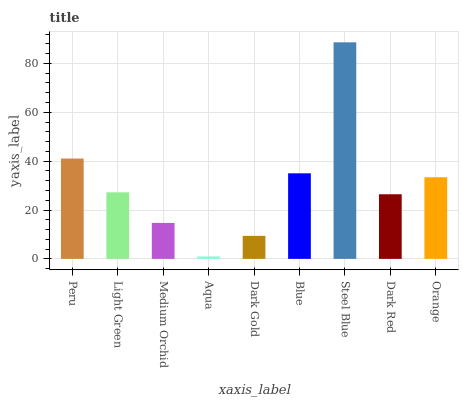Is Light Green the minimum?
Answer yes or no. No. Is Light Green the maximum?
Answer yes or no. No. Is Peru greater than Light Green?
Answer yes or no. Yes. Is Light Green less than Peru?
Answer yes or no. Yes. Is Light Green greater than Peru?
Answer yes or no. No. Is Peru less than Light Green?
Answer yes or no. No. Is Light Green the high median?
Answer yes or no. Yes. Is Light Green the low median?
Answer yes or no. Yes. Is Medium Orchid the high median?
Answer yes or no. No. Is Steel Blue the low median?
Answer yes or no. No. 